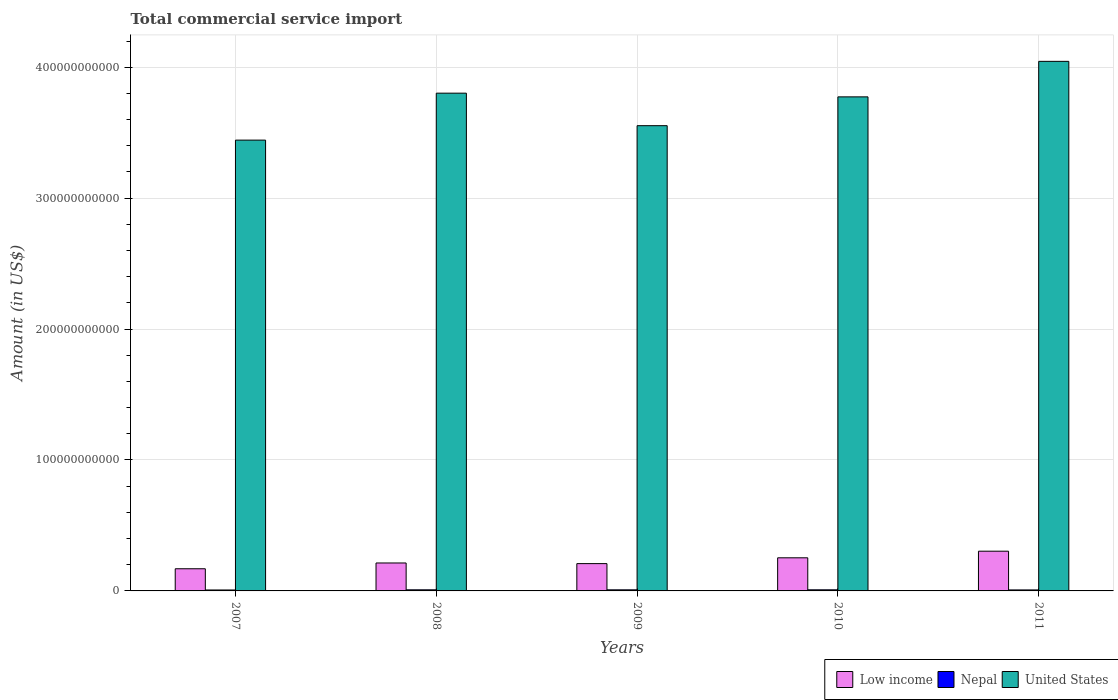How many groups of bars are there?
Keep it short and to the point. 5. Are the number of bars per tick equal to the number of legend labels?
Offer a terse response. Yes. Are the number of bars on each tick of the X-axis equal?
Your answer should be very brief. Yes. How many bars are there on the 4th tick from the left?
Ensure brevity in your answer.  3. What is the total commercial service import in Low income in 2007?
Ensure brevity in your answer.  1.69e+1. Across all years, what is the maximum total commercial service import in Nepal?
Keep it short and to the point. 8.45e+08. Across all years, what is the minimum total commercial service import in United States?
Provide a succinct answer. 3.44e+11. In which year was the total commercial service import in Nepal minimum?
Ensure brevity in your answer.  2007. What is the total total commercial service import in United States in the graph?
Provide a succinct answer. 1.86e+12. What is the difference between the total commercial service import in Nepal in 2007 and that in 2008?
Keep it short and to the point. -1.24e+08. What is the difference between the total commercial service import in United States in 2011 and the total commercial service import in Nepal in 2007?
Keep it short and to the point. 4.04e+11. What is the average total commercial service import in Low income per year?
Provide a short and direct response. 2.30e+1. In the year 2008, what is the difference between the total commercial service import in United States and total commercial service import in Low income?
Your answer should be compact. 3.59e+11. In how many years, is the total commercial service import in Low income greater than 280000000000 US$?
Keep it short and to the point. 0. What is the ratio of the total commercial service import in United States in 2008 to that in 2010?
Make the answer very short. 1.01. Is the total commercial service import in Low income in 2007 less than that in 2008?
Provide a succinct answer. Yes. Is the difference between the total commercial service import in United States in 2009 and 2010 greater than the difference between the total commercial service import in Low income in 2009 and 2010?
Your answer should be very brief. No. What is the difference between the highest and the second highest total commercial service import in Nepal?
Provide a short and direct response. 5.02e+06. What is the difference between the highest and the lowest total commercial service import in Nepal?
Make the answer very short. 1.29e+08. Is the sum of the total commercial service import in Low income in 2008 and 2010 greater than the maximum total commercial service import in United States across all years?
Offer a very short reply. No. What does the 2nd bar from the left in 2007 represents?
Offer a terse response. Nepal. Is it the case that in every year, the sum of the total commercial service import in United States and total commercial service import in Low income is greater than the total commercial service import in Nepal?
Provide a short and direct response. Yes. How many bars are there?
Ensure brevity in your answer.  15. Are all the bars in the graph horizontal?
Offer a very short reply. No. What is the difference between two consecutive major ticks on the Y-axis?
Offer a very short reply. 1.00e+11. Are the values on the major ticks of Y-axis written in scientific E-notation?
Your answer should be very brief. No. How many legend labels are there?
Ensure brevity in your answer.  3. What is the title of the graph?
Ensure brevity in your answer.  Total commercial service import. What is the label or title of the Y-axis?
Your answer should be compact. Amount (in US$). What is the Amount (in US$) in Low income in 2007?
Provide a short and direct response. 1.69e+1. What is the Amount (in US$) of Nepal in 2007?
Make the answer very short. 7.16e+08. What is the Amount (in US$) of United States in 2007?
Your answer should be very brief. 3.44e+11. What is the Amount (in US$) of Low income in 2008?
Provide a succinct answer. 2.13e+1. What is the Amount (in US$) of Nepal in 2008?
Your answer should be compact. 8.40e+08. What is the Amount (in US$) of United States in 2008?
Your answer should be very brief. 3.80e+11. What is the Amount (in US$) of Low income in 2009?
Give a very brief answer. 2.09e+1. What is the Amount (in US$) of Nepal in 2009?
Your response must be concise. 8.28e+08. What is the Amount (in US$) in United States in 2009?
Your answer should be very brief. 3.55e+11. What is the Amount (in US$) of Low income in 2010?
Keep it short and to the point. 2.53e+1. What is the Amount (in US$) of Nepal in 2010?
Provide a succinct answer. 8.45e+08. What is the Amount (in US$) in United States in 2010?
Your answer should be very brief. 3.77e+11. What is the Amount (in US$) of Low income in 2011?
Offer a very short reply. 3.03e+1. What is the Amount (in US$) in Nepal in 2011?
Provide a succinct answer. 7.61e+08. What is the Amount (in US$) of United States in 2011?
Make the answer very short. 4.04e+11. Across all years, what is the maximum Amount (in US$) in Low income?
Make the answer very short. 3.03e+1. Across all years, what is the maximum Amount (in US$) in Nepal?
Your answer should be compact. 8.45e+08. Across all years, what is the maximum Amount (in US$) in United States?
Your response must be concise. 4.04e+11. Across all years, what is the minimum Amount (in US$) in Low income?
Offer a terse response. 1.69e+1. Across all years, what is the minimum Amount (in US$) in Nepal?
Provide a short and direct response. 7.16e+08. Across all years, what is the minimum Amount (in US$) of United States?
Provide a succinct answer. 3.44e+11. What is the total Amount (in US$) in Low income in the graph?
Offer a very short reply. 1.15e+11. What is the total Amount (in US$) of Nepal in the graph?
Make the answer very short. 3.99e+09. What is the total Amount (in US$) of United States in the graph?
Your response must be concise. 1.86e+12. What is the difference between the Amount (in US$) in Low income in 2007 and that in 2008?
Ensure brevity in your answer.  -4.41e+09. What is the difference between the Amount (in US$) in Nepal in 2007 and that in 2008?
Provide a short and direct response. -1.24e+08. What is the difference between the Amount (in US$) in United States in 2007 and that in 2008?
Your answer should be very brief. -3.59e+1. What is the difference between the Amount (in US$) in Low income in 2007 and that in 2009?
Make the answer very short. -3.93e+09. What is the difference between the Amount (in US$) of Nepal in 2007 and that in 2009?
Your answer should be very brief. -1.11e+08. What is the difference between the Amount (in US$) of United States in 2007 and that in 2009?
Offer a terse response. -1.10e+1. What is the difference between the Amount (in US$) of Low income in 2007 and that in 2010?
Your answer should be very brief. -8.36e+09. What is the difference between the Amount (in US$) of Nepal in 2007 and that in 2010?
Keep it short and to the point. -1.29e+08. What is the difference between the Amount (in US$) of United States in 2007 and that in 2010?
Make the answer very short. -3.30e+1. What is the difference between the Amount (in US$) in Low income in 2007 and that in 2011?
Your answer should be compact. -1.34e+1. What is the difference between the Amount (in US$) of Nepal in 2007 and that in 2011?
Offer a very short reply. -4.52e+07. What is the difference between the Amount (in US$) of United States in 2007 and that in 2011?
Offer a very short reply. -6.02e+1. What is the difference between the Amount (in US$) in Low income in 2008 and that in 2009?
Make the answer very short. 4.80e+08. What is the difference between the Amount (in US$) in Nepal in 2008 and that in 2009?
Offer a very short reply. 1.26e+07. What is the difference between the Amount (in US$) of United States in 2008 and that in 2009?
Your answer should be very brief. 2.48e+1. What is the difference between the Amount (in US$) in Low income in 2008 and that in 2010?
Provide a succinct answer. -3.95e+09. What is the difference between the Amount (in US$) of Nepal in 2008 and that in 2010?
Keep it short and to the point. -5.02e+06. What is the difference between the Amount (in US$) in United States in 2008 and that in 2010?
Keep it short and to the point. 2.82e+09. What is the difference between the Amount (in US$) of Low income in 2008 and that in 2011?
Give a very brief answer. -9.01e+09. What is the difference between the Amount (in US$) in Nepal in 2008 and that in 2011?
Your answer should be compact. 7.88e+07. What is the difference between the Amount (in US$) in United States in 2008 and that in 2011?
Your response must be concise. -2.43e+1. What is the difference between the Amount (in US$) in Low income in 2009 and that in 2010?
Give a very brief answer. -4.43e+09. What is the difference between the Amount (in US$) of Nepal in 2009 and that in 2010?
Provide a succinct answer. -1.76e+07. What is the difference between the Amount (in US$) in United States in 2009 and that in 2010?
Your answer should be very brief. -2.20e+1. What is the difference between the Amount (in US$) of Low income in 2009 and that in 2011?
Provide a short and direct response. -9.49e+09. What is the difference between the Amount (in US$) in Nepal in 2009 and that in 2011?
Offer a very short reply. 6.61e+07. What is the difference between the Amount (in US$) in United States in 2009 and that in 2011?
Provide a short and direct response. -4.91e+1. What is the difference between the Amount (in US$) in Low income in 2010 and that in 2011?
Give a very brief answer. -5.06e+09. What is the difference between the Amount (in US$) of Nepal in 2010 and that in 2011?
Give a very brief answer. 8.38e+07. What is the difference between the Amount (in US$) in United States in 2010 and that in 2011?
Offer a terse response. -2.71e+1. What is the difference between the Amount (in US$) in Low income in 2007 and the Amount (in US$) in Nepal in 2008?
Your answer should be compact. 1.61e+1. What is the difference between the Amount (in US$) of Low income in 2007 and the Amount (in US$) of United States in 2008?
Your response must be concise. -3.63e+11. What is the difference between the Amount (in US$) of Nepal in 2007 and the Amount (in US$) of United States in 2008?
Ensure brevity in your answer.  -3.79e+11. What is the difference between the Amount (in US$) in Low income in 2007 and the Amount (in US$) in Nepal in 2009?
Ensure brevity in your answer.  1.61e+1. What is the difference between the Amount (in US$) in Low income in 2007 and the Amount (in US$) in United States in 2009?
Keep it short and to the point. -3.38e+11. What is the difference between the Amount (in US$) of Nepal in 2007 and the Amount (in US$) of United States in 2009?
Keep it short and to the point. -3.55e+11. What is the difference between the Amount (in US$) in Low income in 2007 and the Amount (in US$) in Nepal in 2010?
Provide a succinct answer. 1.61e+1. What is the difference between the Amount (in US$) in Low income in 2007 and the Amount (in US$) in United States in 2010?
Your answer should be compact. -3.60e+11. What is the difference between the Amount (in US$) in Nepal in 2007 and the Amount (in US$) in United States in 2010?
Provide a succinct answer. -3.77e+11. What is the difference between the Amount (in US$) in Low income in 2007 and the Amount (in US$) in Nepal in 2011?
Make the answer very short. 1.62e+1. What is the difference between the Amount (in US$) in Low income in 2007 and the Amount (in US$) in United States in 2011?
Ensure brevity in your answer.  -3.88e+11. What is the difference between the Amount (in US$) of Nepal in 2007 and the Amount (in US$) of United States in 2011?
Ensure brevity in your answer.  -4.04e+11. What is the difference between the Amount (in US$) of Low income in 2008 and the Amount (in US$) of Nepal in 2009?
Your response must be concise. 2.05e+1. What is the difference between the Amount (in US$) of Low income in 2008 and the Amount (in US$) of United States in 2009?
Your answer should be very brief. -3.34e+11. What is the difference between the Amount (in US$) of Nepal in 2008 and the Amount (in US$) of United States in 2009?
Keep it short and to the point. -3.55e+11. What is the difference between the Amount (in US$) of Low income in 2008 and the Amount (in US$) of Nepal in 2010?
Your answer should be compact. 2.05e+1. What is the difference between the Amount (in US$) in Low income in 2008 and the Amount (in US$) in United States in 2010?
Offer a very short reply. -3.56e+11. What is the difference between the Amount (in US$) in Nepal in 2008 and the Amount (in US$) in United States in 2010?
Offer a very short reply. -3.77e+11. What is the difference between the Amount (in US$) of Low income in 2008 and the Amount (in US$) of Nepal in 2011?
Provide a succinct answer. 2.06e+1. What is the difference between the Amount (in US$) of Low income in 2008 and the Amount (in US$) of United States in 2011?
Your response must be concise. -3.83e+11. What is the difference between the Amount (in US$) of Nepal in 2008 and the Amount (in US$) of United States in 2011?
Provide a short and direct response. -4.04e+11. What is the difference between the Amount (in US$) in Low income in 2009 and the Amount (in US$) in Nepal in 2010?
Provide a short and direct response. 2.00e+1. What is the difference between the Amount (in US$) of Low income in 2009 and the Amount (in US$) of United States in 2010?
Provide a succinct answer. -3.56e+11. What is the difference between the Amount (in US$) of Nepal in 2009 and the Amount (in US$) of United States in 2010?
Provide a short and direct response. -3.77e+11. What is the difference between the Amount (in US$) in Low income in 2009 and the Amount (in US$) in Nepal in 2011?
Make the answer very short. 2.01e+1. What is the difference between the Amount (in US$) of Low income in 2009 and the Amount (in US$) of United States in 2011?
Give a very brief answer. -3.84e+11. What is the difference between the Amount (in US$) in Nepal in 2009 and the Amount (in US$) in United States in 2011?
Ensure brevity in your answer.  -4.04e+11. What is the difference between the Amount (in US$) of Low income in 2010 and the Amount (in US$) of Nepal in 2011?
Keep it short and to the point. 2.45e+1. What is the difference between the Amount (in US$) in Low income in 2010 and the Amount (in US$) in United States in 2011?
Your answer should be compact. -3.79e+11. What is the difference between the Amount (in US$) in Nepal in 2010 and the Amount (in US$) in United States in 2011?
Give a very brief answer. -4.04e+11. What is the average Amount (in US$) of Low income per year?
Offer a terse response. 2.30e+1. What is the average Amount (in US$) in Nepal per year?
Your answer should be compact. 7.98e+08. What is the average Amount (in US$) of United States per year?
Your response must be concise. 3.72e+11. In the year 2007, what is the difference between the Amount (in US$) in Low income and Amount (in US$) in Nepal?
Keep it short and to the point. 1.62e+1. In the year 2007, what is the difference between the Amount (in US$) in Low income and Amount (in US$) in United States?
Your answer should be compact. -3.27e+11. In the year 2007, what is the difference between the Amount (in US$) in Nepal and Amount (in US$) in United States?
Offer a terse response. -3.44e+11. In the year 2008, what is the difference between the Amount (in US$) in Low income and Amount (in US$) in Nepal?
Make the answer very short. 2.05e+1. In the year 2008, what is the difference between the Amount (in US$) in Low income and Amount (in US$) in United States?
Provide a short and direct response. -3.59e+11. In the year 2008, what is the difference between the Amount (in US$) of Nepal and Amount (in US$) of United States?
Give a very brief answer. -3.79e+11. In the year 2009, what is the difference between the Amount (in US$) of Low income and Amount (in US$) of Nepal?
Give a very brief answer. 2.00e+1. In the year 2009, what is the difference between the Amount (in US$) in Low income and Amount (in US$) in United States?
Offer a very short reply. -3.34e+11. In the year 2009, what is the difference between the Amount (in US$) in Nepal and Amount (in US$) in United States?
Your answer should be compact. -3.55e+11. In the year 2010, what is the difference between the Amount (in US$) of Low income and Amount (in US$) of Nepal?
Give a very brief answer. 2.44e+1. In the year 2010, what is the difference between the Amount (in US$) in Low income and Amount (in US$) in United States?
Your answer should be compact. -3.52e+11. In the year 2010, what is the difference between the Amount (in US$) in Nepal and Amount (in US$) in United States?
Your answer should be compact. -3.77e+11. In the year 2011, what is the difference between the Amount (in US$) of Low income and Amount (in US$) of Nepal?
Provide a succinct answer. 2.96e+1. In the year 2011, what is the difference between the Amount (in US$) in Low income and Amount (in US$) in United States?
Offer a terse response. -3.74e+11. In the year 2011, what is the difference between the Amount (in US$) of Nepal and Amount (in US$) of United States?
Your answer should be very brief. -4.04e+11. What is the ratio of the Amount (in US$) in Low income in 2007 to that in 2008?
Give a very brief answer. 0.79. What is the ratio of the Amount (in US$) of Nepal in 2007 to that in 2008?
Your answer should be compact. 0.85. What is the ratio of the Amount (in US$) in United States in 2007 to that in 2008?
Give a very brief answer. 0.91. What is the ratio of the Amount (in US$) in Low income in 2007 to that in 2009?
Offer a very short reply. 0.81. What is the ratio of the Amount (in US$) of Nepal in 2007 to that in 2009?
Make the answer very short. 0.87. What is the ratio of the Amount (in US$) in Low income in 2007 to that in 2010?
Your answer should be compact. 0.67. What is the ratio of the Amount (in US$) in Nepal in 2007 to that in 2010?
Your answer should be compact. 0.85. What is the ratio of the Amount (in US$) of United States in 2007 to that in 2010?
Ensure brevity in your answer.  0.91. What is the ratio of the Amount (in US$) in Low income in 2007 to that in 2011?
Provide a succinct answer. 0.56. What is the ratio of the Amount (in US$) in Nepal in 2007 to that in 2011?
Provide a short and direct response. 0.94. What is the ratio of the Amount (in US$) of United States in 2007 to that in 2011?
Give a very brief answer. 0.85. What is the ratio of the Amount (in US$) in Nepal in 2008 to that in 2009?
Give a very brief answer. 1.02. What is the ratio of the Amount (in US$) in United States in 2008 to that in 2009?
Ensure brevity in your answer.  1.07. What is the ratio of the Amount (in US$) in Low income in 2008 to that in 2010?
Your answer should be very brief. 0.84. What is the ratio of the Amount (in US$) of Nepal in 2008 to that in 2010?
Keep it short and to the point. 0.99. What is the ratio of the Amount (in US$) of United States in 2008 to that in 2010?
Make the answer very short. 1.01. What is the ratio of the Amount (in US$) of Low income in 2008 to that in 2011?
Provide a short and direct response. 0.7. What is the ratio of the Amount (in US$) in Nepal in 2008 to that in 2011?
Keep it short and to the point. 1.1. What is the ratio of the Amount (in US$) in United States in 2008 to that in 2011?
Your answer should be very brief. 0.94. What is the ratio of the Amount (in US$) of Low income in 2009 to that in 2010?
Provide a succinct answer. 0.82. What is the ratio of the Amount (in US$) of Nepal in 2009 to that in 2010?
Make the answer very short. 0.98. What is the ratio of the Amount (in US$) in United States in 2009 to that in 2010?
Your answer should be compact. 0.94. What is the ratio of the Amount (in US$) in Low income in 2009 to that in 2011?
Offer a terse response. 0.69. What is the ratio of the Amount (in US$) in Nepal in 2009 to that in 2011?
Ensure brevity in your answer.  1.09. What is the ratio of the Amount (in US$) in United States in 2009 to that in 2011?
Your answer should be very brief. 0.88. What is the ratio of the Amount (in US$) in Low income in 2010 to that in 2011?
Provide a short and direct response. 0.83. What is the ratio of the Amount (in US$) in Nepal in 2010 to that in 2011?
Give a very brief answer. 1.11. What is the ratio of the Amount (in US$) of United States in 2010 to that in 2011?
Offer a terse response. 0.93. What is the difference between the highest and the second highest Amount (in US$) of Low income?
Provide a short and direct response. 5.06e+09. What is the difference between the highest and the second highest Amount (in US$) of Nepal?
Make the answer very short. 5.02e+06. What is the difference between the highest and the second highest Amount (in US$) of United States?
Provide a short and direct response. 2.43e+1. What is the difference between the highest and the lowest Amount (in US$) of Low income?
Offer a terse response. 1.34e+1. What is the difference between the highest and the lowest Amount (in US$) in Nepal?
Your response must be concise. 1.29e+08. What is the difference between the highest and the lowest Amount (in US$) of United States?
Offer a terse response. 6.02e+1. 